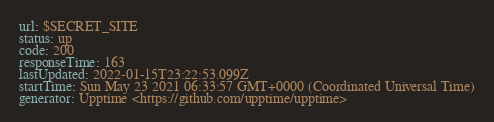Convert code to text. <code><loc_0><loc_0><loc_500><loc_500><_YAML_>url: $SECRET_SITE
status: up
code: 200
responseTime: 163
lastUpdated: 2022-01-15T23:22:53.099Z
startTime: Sun May 23 2021 06:33:57 GMT+0000 (Coordinated Universal Time)
generator: Upptime <https://github.com/upptime/upptime>
</code> 